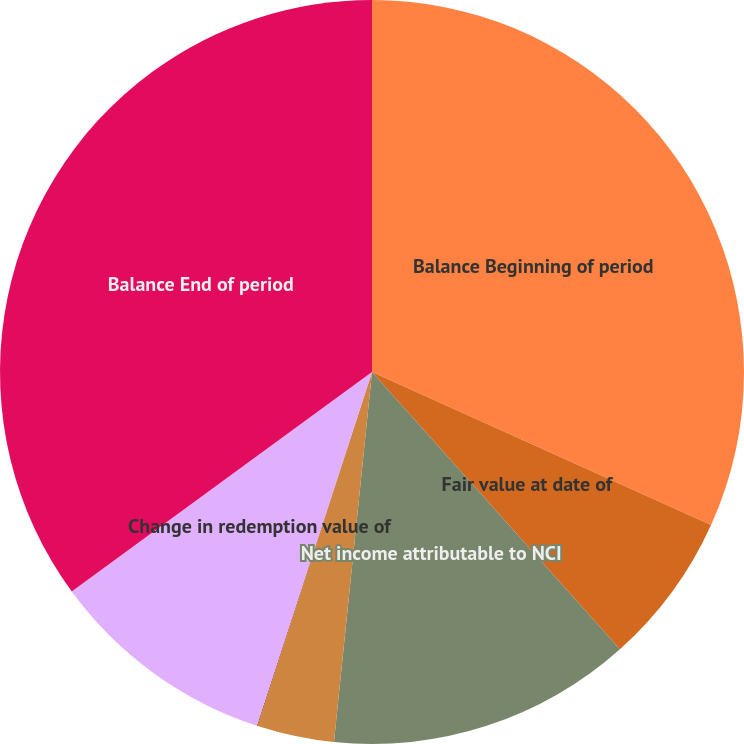<chart> <loc_0><loc_0><loc_500><loc_500><pie_chart><fcel>Balance Beginning of period<fcel>Fair value at date of<fcel>Net income attributable to NCI<fcel>Other comprehensive income<fcel>Purchase of shares from NCI<fcel>Change in redemption value of<fcel>Balance End of period<nl><fcel>31.75%<fcel>6.64%<fcel>13.24%<fcel>3.34%<fcel>0.04%<fcel>9.94%<fcel>35.05%<nl></chart> 